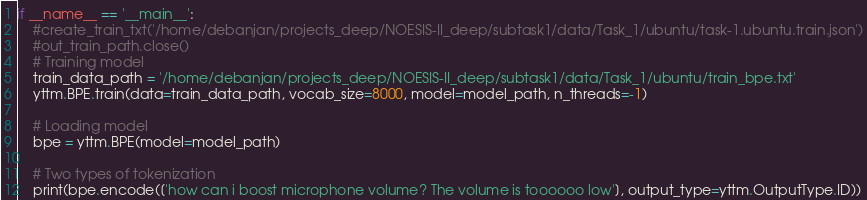Convert code to text. <code><loc_0><loc_0><loc_500><loc_500><_Python_>

if __name__ == '__main__':
    #create_train_txt('/home/debanjan/projects_deep/NOESIS-II_deep/subtask1/data/Task_1/ubuntu/task-1.ubuntu.train.json')
    #out_train_path.close()
    # Training model
    train_data_path = '/home/debanjan/projects_deep/NOESIS-II_deep/subtask1/data/Task_1/ubuntu/train_bpe.txt'
    yttm.BPE.train(data=train_data_path, vocab_size=8000, model=model_path, n_threads=-1)

    # Loading model
    bpe = yttm.BPE(model=model_path)

    # Two types of tokenization
    print(bpe.encode(['how can i boost microphone volume? The volume is toooooo low'], output_type=yttm.OutputType.ID))</code> 